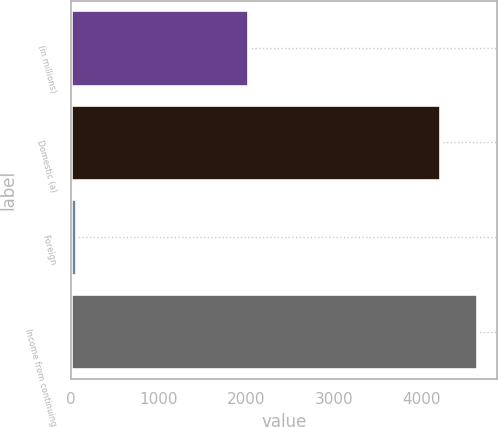<chart> <loc_0><loc_0><loc_500><loc_500><bar_chart><fcel>(in millions)<fcel>Domestic (a)<fcel>Foreign<fcel>Income from continuing<nl><fcel>2017<fcel>4207<fcel>59<fcel>4627.7<nl></chart> 